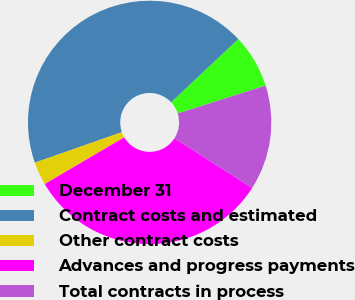Convert chart. <chart><loc_0><loc_0><loc_500><loc_500><pie_chart><fcel>December 31<fcel>Contract costs and estimated<fcel>Other contract costs<fcel>Advances and progress payments<fcel>Total contracts in process<nl><fcel>7.11%<fcel>43.37%<fcel>3.08%<fcel>32.48%<fcel>13.96%<nl></chart> 